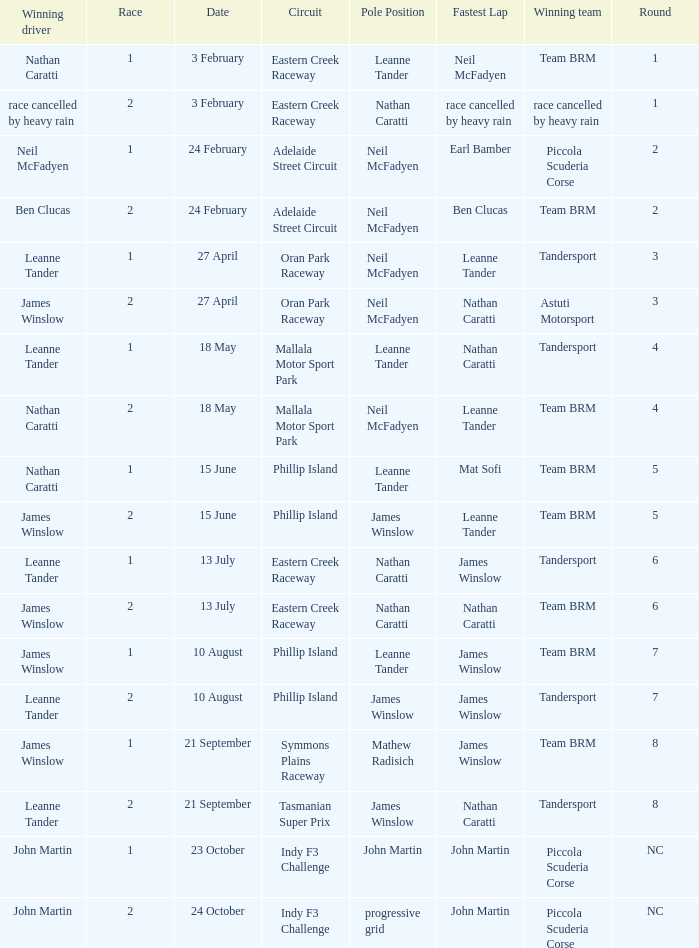What is the highest race number in the Phillip Island circuit with James Winslow as the winning driver and pole position? 2.0. 